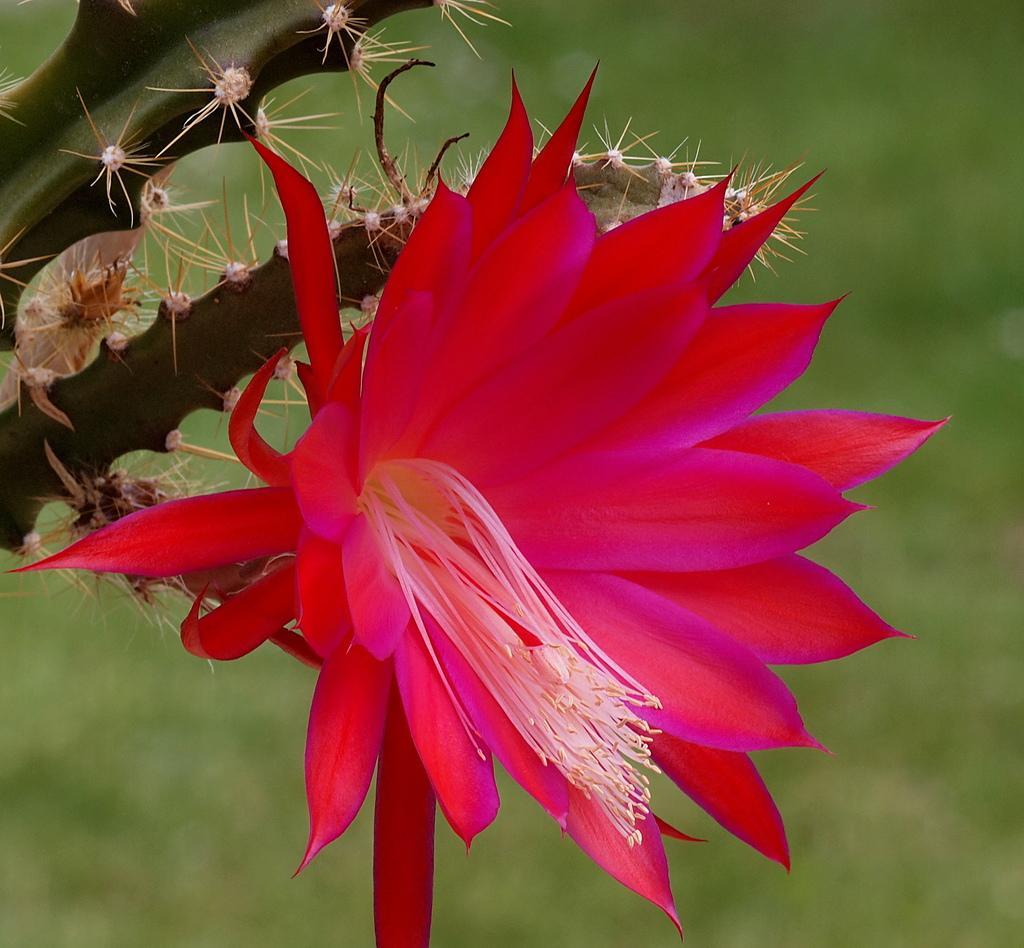Can you describe this image briefly? In this image there is a red color flower to a cactus plant. Background is green in color. 